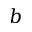Convert formula to latex. <formula><loc_0><loc_0><loc_500><loc_500>b</formula> 